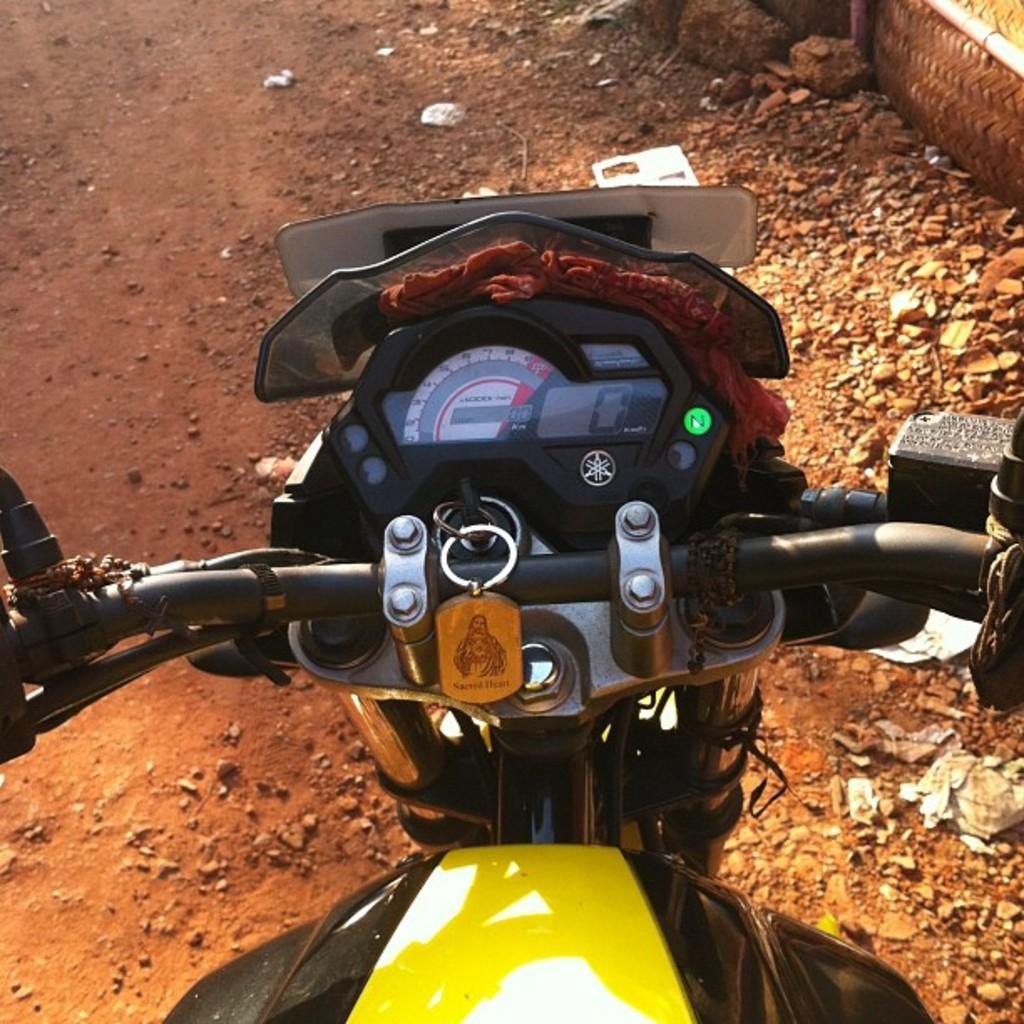Please provide a concise description of this image. In this image we can see bike which is of yellow and black color is on road. 